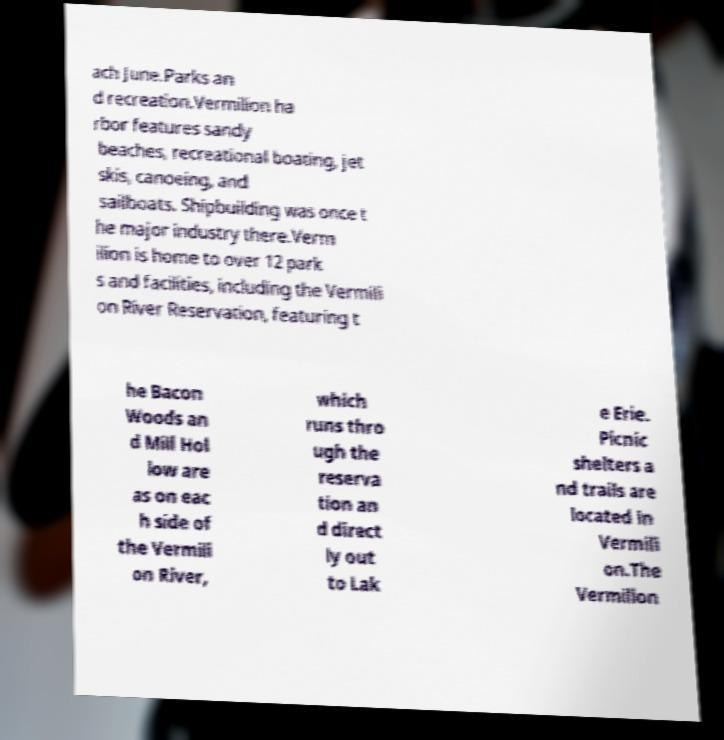Can you read and provide the text displayed in the image?This photo seems to have some interesting text. Can you extract and type it out for me? ach June.Parks an d recreation.Vermilion ha rbor features sandy beaches, recreational boating, jet skis, canoeing, and sailboats. Shipbuilding was once t he major industry there.Verm ilion is home to over 12 park s and facilities, including the Vermili on River Reservation, featuring t he Bacon Woods an d Mill Hol low are as on eac h side of the Vermili on River, which runs thro ugh the reserva tion an d direct ly out to Lak e Erie. Picnic shelters a nd trails are located in Vermili on.The Vermilion 